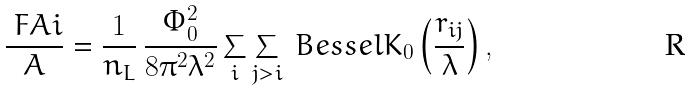Convert formula to latex. <formula><loc_0><loc_0><loc_500><loc_500>\frac { \ F A i } { A } = \frac { 1 } { n _ { L } } \, \frac { \Phi _ { 0 } ^ { 2 } } { 8 \pi ^ { 2 } \lambda ^ { 2 } } \sum _ { i } \sum _ { j > i } \ B e s s e l K _ { 0 } \left ( \frac { r _ { i j } } { \lambda } \right ) ,</formula> 